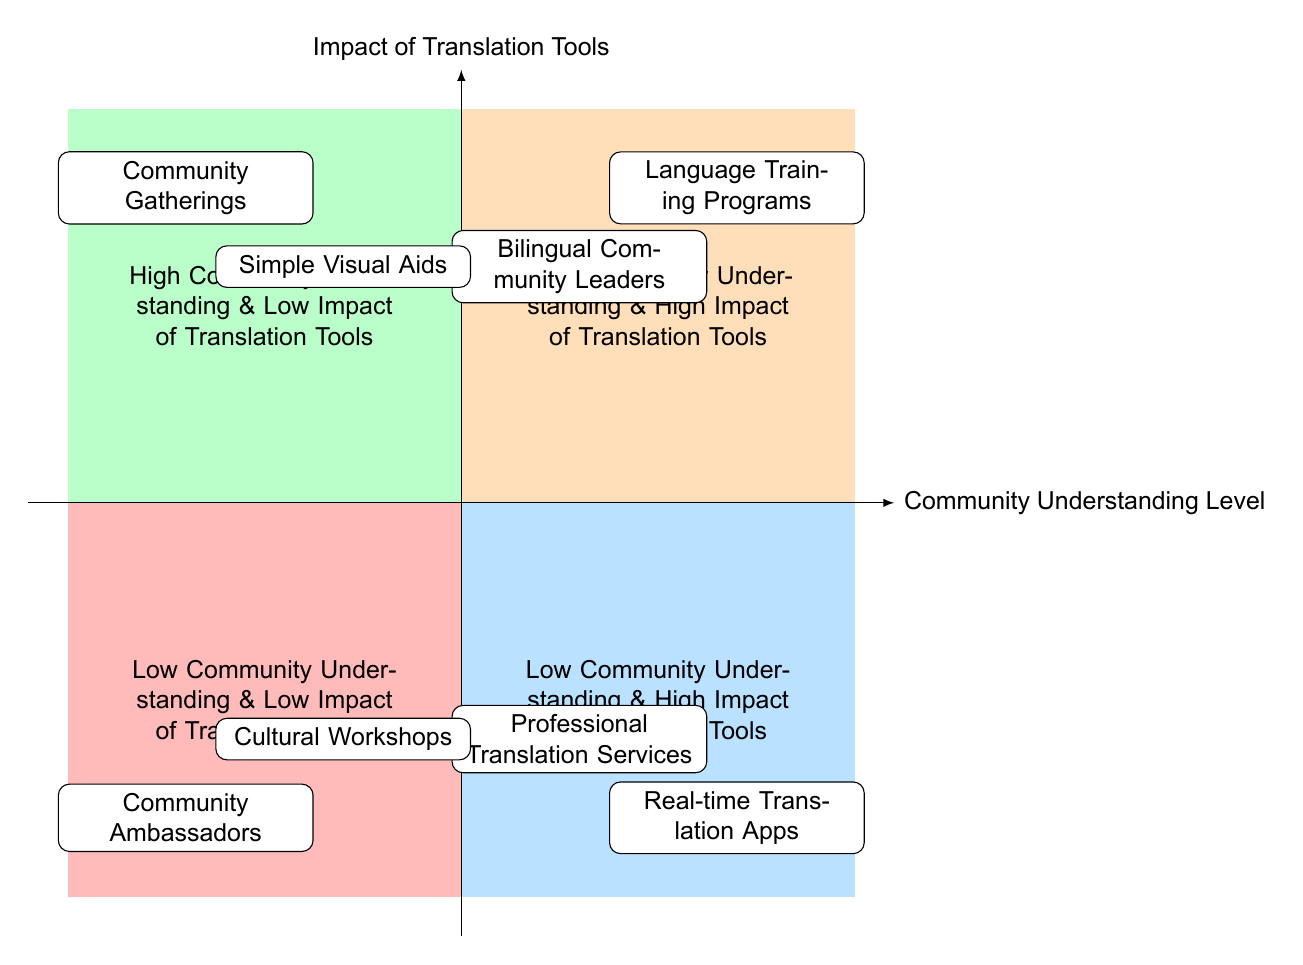What are the two elements in the "High Community Understanding & High Impact of Translation Tools" quadrant? The "High Community Understanding & High Impact of Translation Tools" quadrant contains two elements: "Language Training Programs" and "Bilingual Community Leaders".
Answer: Language Training Programs, Bilingual Community Leaders How many elements are in the "Low Community Understanding & Low Impact of Translation Tools" quadrant? The "Low Community Understanding & Low Impact of Translation Tools" quadrant has two elements: "Community Ambassadors" and "Cultural Workshops". Therefore, the total count is two.
Answer: 2 Which quadrant has "Real-time Translation Apps" as an element? "Real-time Translation Apps" is located in the "Low Community Understanding & High Impact of Translation Tools" quadrant.
Answer: Low Community Understanding & High Impact of Translation Tools What is suggested for communities that have a high understanding but low impact from translation tools? For communities with high understanding and low impact from translation tools, suggested elements include "Community Gatherings" and "Simple Visual Aids".
Answer: Community Gatherings, Simple Visual Aids Which element is positioned in the bottom right quadrant, and what is it about? The bottom right quadrant, labeled "Low Community Understanding & High Impact of Translation Tools", includes "Real-time Translation Apps", which refers to using applications for translation during meetings.
Answer: Real-time Translation Apps How does "Bilingual Community Leaders" affect the understanding levels in communities? "Bilingual Community Leaders" positively impacts understanding levels as they help bridge communication gaps, ensuring both local and project languages are understood effectively.
Answer: Positive impact on understanding levels What could be organized to improve communication in the "Low Community Understanding & Low Impact of Translation Tools" quadrant? This quadrant suggests organizing "Cultural Workshops" which aim to bridge cultural and language gaps, enhancing overall communication.
Answer: Cultural Workshops How does "Professional Translation Services" relate to community understanding? "Professional Translation Services" is employed to support communities with low understanding levels, ensuring accurate communication in important discussions or documents.
Answer: Supporting low understanding levels What do "Simple Visual Aids" provide for communities with high understanding? "Simple Visual Aids" help enhance understanding by supplementing verbal communication through universally understood symbols and images, which is helpful for returning to high impact strategies.
Answer: Supplementing verbal communication 